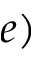<formula> <loc_0><loc_0><loc_500><loc_500>e )</formula> 